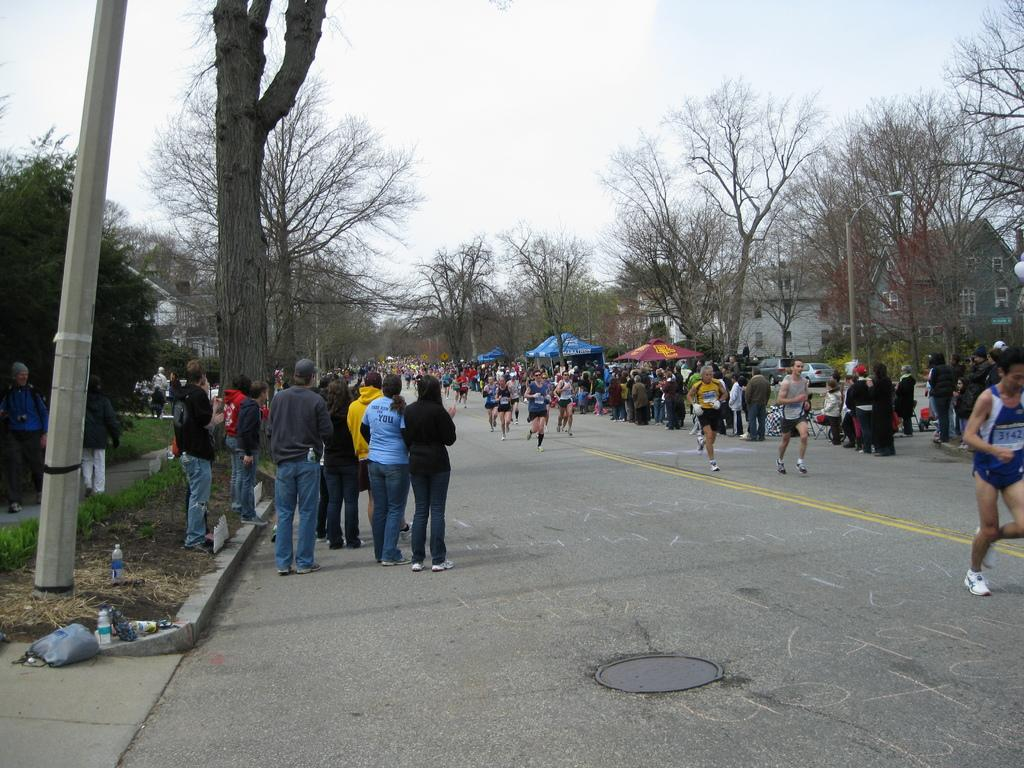What is the main feature of the image? The main feature of the image is a huge crowd on the road. What can be seen around the road? There are trees and houses around the road. What type of toothbrush is being used by the crowd in the image? There is no toothbrush present in the image; it features a huge crowd on the road. What kind of flowers can be seen growing on the road? There are no flowers growing on the road in the image. 